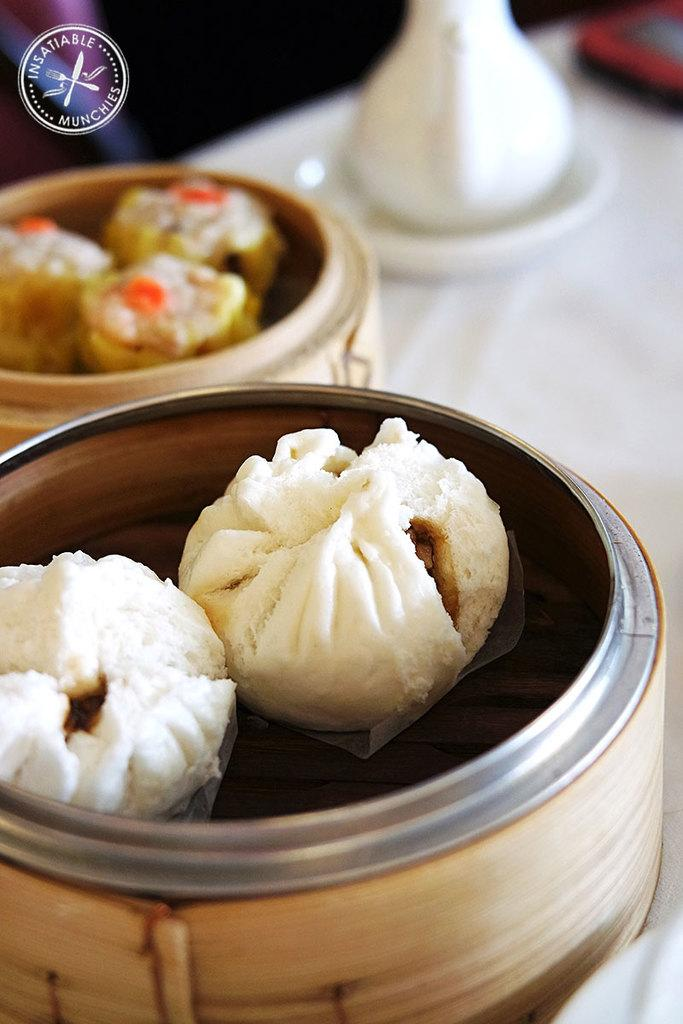<image>
Summarize the visual content of the image. some dumplings in bamboo holders from a place called Insatiable Munchies 